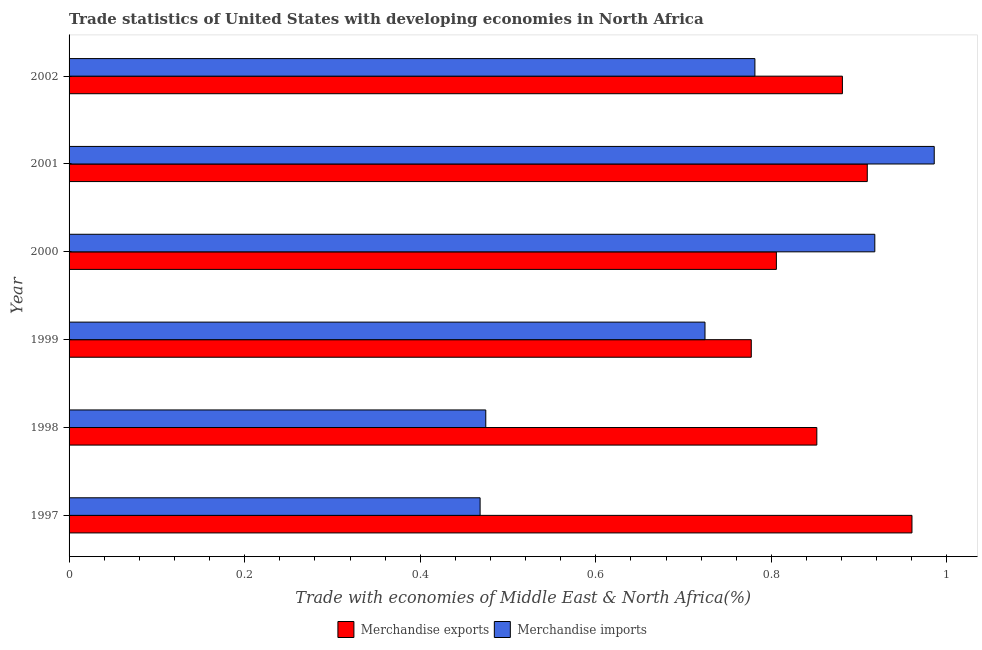How many different coloured bars are there?
Provide a short and direct response. 2. Are the number of bars per tick equal to the number of legend labels?
Your response must be concise. Yes. How many bars are there on the 6th tick from the top?
Give a very brief answer. 2. What is the label of the 3rd group of bars from the top?
Offer a terse response. 2000. What is the merchandise exports in 1997?
Keep it short and to the point. 0.96. Across all years, what is the maximum merchandise imports?
Keep it short and to the point. 0.99. Across all years, what is the minimum merchandise exports?
Give a very brief answer. 0.78. In which year was the merchandise imports maximum?
Provide a short and direct response. 2001. In which year was the merchandise imports minimum?
Offer a terse response. 1997. What is the total merchandise exports in the graph?
Your answer should be very brief. 5.18. What is the difference between the merchandise imports in 1998 and that in 2000?
Your response must be concise. -0.44. What is the difference between the merchandise imports in 2002 and the merchandise exports in 1998?
Offer a terse response. -0.07. What is the average merchandise exports per year?
Offer a terse response. 0.86. In the year 2000, what is the difference between the merchandise imports and merchandise exports?
Give a very brief answer. 0.11. In how many years, is the merchandise exports greater than 0.7200000000000001 %?
Your answer should be very brief. 6. What is the ratio of the merchandise imports in 2001 to that in 2002?
Offer a terse response. 1.26. Is the merchandise exports in 1997 less than that in 2002?
Offer a terse response. No. What is the difference between the highest and the second highest merchandise imports?
Your answer should be very brief. 0.07. What is the difference between the highest and the lowest merchandise exports?
Your response must be concise. 0.18. What does the 1st bar from the top in 1999 represents?
Provide a short and direct response. Merchandise imports. What does the 2nd bar from the bottom in 2001 represents?
Your answer should be very brief. Merchandise imports. How many bars are there?
Give a very brief answer. 12. Are all the bars in the graph horizontal?
Provide a succinct answer. Yes. What is the difference between two consecutive major ticks on the X-axis?
Ensure brevity in your answer.  0.2. Are the values on the major ticks of X-axis written in scientific E-notation?
Your answer should be compact. No. Where does the legend appear in the graph?
Provide a succinct answer. Bottom center. What is the title of the graph?
Keep it short and to the point. Trade statistics of United States with developing economies in North Africa. Does "Chemicals" appear as one of the legend labels in the graph?
Give a very brief answer. No. What is the label or title of the X-axis?
Give a very brief answer. Trade with economies of Middle East & North Africa(%). What is the Trade with economies of Middle East & North Africa(%) of Merchandise exports in 1997?
Offer a very short reply. 0.96. What is the Trade with economies of Middle East & North Africa(%) in Merchandise imports in 1997?
Your answer should be very brief. 0.47. What is the Trade with economies of Middle East & North Africa(%) in Merchandise exports in 1998?
Provide a succinct answer. 0.85. What is the Trade with economies of Middle East & North Africa(%) in Merchandise imports in 1998?
Your answer should be compact. 0.47. What is the Trade with economies of Middle East & North Africa(%) of Merchandise exports in 1999?
Your answer should be very brief. 0.78. What is the Trade with economies of Middle East & North Africa(%) in Merchandise imports in 1999?
Your response must be concise. 0.72. What is the Trade with economies of Middle East & North Africa(%) in Merchandise exports in 2000?
Ensure brevity in your answer.  0.81. What is the Trade with economies of Middle East & North Africa(%) of Merchandise imports in 2000?
Provide a succinct answer. 0.92. What is the Trade with economies of Middle East & North Africa(%) of Merchandise exports in 2001?
Your response must be concise. 0.91. What is the Trade with economies of Middle East & North Africa(%) in Merchandise imports in 2001?
Your response must be concise. 0.99. What is the Trade with economies of Middle East & North Africa(%) in Merchandise exports in 2002?
Provide a short and direct response. 0.88. What is the Trade with economies of Middle East & North Africa(%) in Merchandise imports in 2002?
Your answer should be very brief. 0.78. Across all years, what is the maximum Trade with economies of Middle East & North Africa(%) of Merchandise exports?
Provide a succinct answer. 0.96. Across all years, what is the maximum Trade with economies of Middle East & North Africa(%) of Merchandise imports?
Give a very brief answer. 0.99. Across all years, what is the minimum Trade with economies of Middle East & North Africa(%) of Merchandise exports?
Provide a succinct answer. 0.78. Across all years, what is the minimum Trade with economies of Middle East & North Africa(%) in Merchandise imports?
Your answer should be compact. 0.47. What is the total Trade with economies of Middle East & North Africa(%) of Merchandise exports in the graph?
Keep it short and to the point. 5.18. What is the total Trade with economies of Middle East & North Africa(%) of Merchandise imports in the graph?
Offer a terse response. 4.35. What is the difference between the Trade with economies of Middle East & North Africa(%) of Merchandise exports in 1997 and that in 1998?
Ensure brevity in your answer.  0.11. What is the difference between the Trade with economies of Middle East & North Africa(%) in Merchandise imports in 1997 and that in 1998?
Ensure brevity in your answer.  -0.01. What is the difference between the Trade with economies of Middle East & North Africa(%) in Merchandise exports in 1997 and that in 1999?
Keep it short and to the point. 0.18. What is the difference between the Trade with economies of Middle East & North Africa(%) of Merchandise imports in 1997 and that in 1999?
Ensure brevity in your answer.  -0.26. What is the difference between the Trade with economies of Middle East & North Africa(%) of Merchandise exports in 1997 and that in 2000?
Make the answer very short. 0.15. What is the difference between the Trade with economies of Middle East & North Africa(%) in Merchandise imports in 1997 and that in 2000?
Your answer should be very brief. -0.45. What is the difference between the Trade with economies of Middle East & North Africa(%) in Merchandise exports in 1997 and that in 2001?
Offer a terse response. 0.05. What is the difference between the Trade with economies of Middle East & North Africa(%) of Merchandise imports in 1997 and that in 2001?
Provide a succinct answer. -0.52. What is the difference between the Trade with economies of Middle East & North Africa(%) in Merchandise exports in 1997 and that in 2002?
Provide a succinct answer. 0.08. What is the difference between the Trade with economies of Middle East & North Africa(%) of Merchandise imports in 1997 and that in 2002?
Provide a succinct answer. -0.31. What is the difference between the Trade with economies of Middle East & North Africa(%) in Merchandise exports in 1998 and that in 1999?
Your response must be concise. 0.07. What is the difference between the Trade with economies of Middle East & North Africa(%) in Merchandise imports in 1998 and that in 1999?
Provide a short and direct response. -0.25. What is the difference between the Trade with economies of Middle East & North Africa(%) of Merchandise exports in 1998 and that in 2000?
Offer a very short reply. 0.05. What is the difference between the Trade with economies of Middle East & North Africa(%) in Merchandise imports in 1998 and that in 2000?
Your response must be concise. -0.44. What is the difference between the Trade with economies of Middle East & North Africa(%) in Merchandise exports in 1998 and that in 2001?
Ensure brevity in your answer.  -0.06. What is the difference between the Trade with economies of Middle East & North Africa(%) of Merchandise imports in 1998 and that in 2001?
Offer a terse response. -0.51. What is the difference between the Trade with economies of Middle East & North Africa(%) of Merchandise exports in 1998 and that in 2002?
Your answer should be very brief. -0.03. What is the difference between the Trade with economies of Middle East & North Africa(%) in Merchandise imports in 1998 and that in 2002?
Give a very brief answer. -0.31. What is the difference between the Trade with economies of Middle East & North Africa(%) of Merchandise exports in 1999 and that in 2000?
Your response must be concise. -0.03. What is the difference between the Trade with economies of Middle East & North Africa(%) of Merchandise imports in 1999 and that in 2000?
Give a very brief answer. -0.19. What is the difference between the Trade with economies of Middle East & North Africa(%) in Merchandise exports in 1999 and that in 2001?
Your answer should be compact. -0.13. What is the difference between the Trade with economies of Middle East & North Africa(%) of Merchandise imports in 1999 and that in 2001?
Your answer should be compact. -0.26. What is the difference between the Trade with economies of Middle East & North Africa(%) of Merchandise exports in 1999 and that in 2002?
Your response must be concise. -0.1. What is the difference between the Trade with economies of Middle East & North Africa(%) of Merchandise imports in 1999 and that in 2002?
Your response must be concise. -0.06. What is the difference between the Trade with economies of Middle East & North Africa(%) in Merchandise exports in 2000 and that in 2001?
Give a very brief answer. -0.1. What is the difference between the Trade with economies of Middle East & North Africa(%) of Merchandise imports in 2000 and that in 2001?
Your response must be concise. -0.07. What is the difference between the Trade with economies of Middle East & North Africa(%) of Merchandise exports in 2000 and that in 2002?
Offer a terse response. -0.08. What is the difference between the Trade with economies of Middle East & North Africa(%) in Merchandise imports in 2000 and that in 2002?
Your answer should be very brief. 0.14. What is the difference between the Trade with economies of Middle East & North Africa(%) of Merchandise exports in 2001 and that in 2002?
Your answer should be very brief. 0.03. What is the difference between the Trade with economies of Middle East & North Africa(%) of Merchandise imports in 2001 and that in 2002?
Your answer should be very brief. 0.2. What is the difference between the Trade with economies of Middle East & North Africa(%) in Merchandise exports in 1997 and the Trade with economies of Middle East & North Africa(%) in Merchandise imports in 1998?
Keep it short and to the point. 0.49. What is the difference between the Trade with economies of Middle East & North Africa(%) in Merchandise exports in 1997 and the Trade with economies of Middle East & North Africa(%) in Merchandise imports in 1999?
Provide a succinct answer. 0.24. What is the difference between the Trade with economies of Middle East & North Africa(%) of Merchandise exports in 1997 and the Trade with economies of Middle East & North Africa(%) of Merchandise imports in 2000?
Offer a terse response. 0.04. What is the difference between the Trade with economies of Middle East & North Africa(%) of Merchandise exports in 1997 and the Trade with economies of Middle East & North Africa(%) of Merchandise imports in 2001?
Offer a terse response. -0.03. What is the difference between the Trade with economies of Middle East & North Africa(%) of Merchandise exports in 1997 and the Trade with economies of Middle East & North Africa(%) of Merchandise imports in 2002?
Offer a very short reply. 0.18. What is the difference between the Trade with economies of Middle East & North Africa(%) of Merchandise exports in 1998 and the Trade with economies of Middle East & North Africa(%) of Merchandise imports in 1999?
Ensure brevity in your answer.  0.13. What is the difference between the Trade with economies of Middle East & North Africa(%) of Merchandise exports in 1998 and the Trade with economies of Middle East & North Africa(%) of Merchandise imports in 2000?
Offer a very short reply. -0.07. What is the difference between the Trade with economies of Middle East & North Africa(%) of Merchandise exports in 1998 and the Trade with economies of Middle East & North Africa(%) of Merchandise imports in 2001?
Your response must be concise. -0.13. What is the difference between the Trade with economies of Middle East & North Africa(%) of Merchandise exports in 1998 and the Trade with economies of Middle East & North Africa(%) of Merchandise imports in 2002?
Your response must be concise. 0.07. What is the difference between the Trade with economies of Middle East & North Africa(%) of Merchandise exports in 1999 and the Trade with economies of Middle East & North Africa(%) of Merchandise imports in 2000?
Your answer should be very brief. -0.14. What is the difference between the Trade with economies of Middle East & North Africa(%) of Merchandise exports in 1999 and the Trade with economies of Middle East & North Africa(%) of Merchandise imports in 2001?
Ensure brevity in your answer.  -0.21. What is the difference between the Trade with economies of Middle East & North Africa(%) in Merchandise exports in 1999 and the Trade with economies of Middle East & North Africa(%) in Merchandise imports in 2002?
Offer a terse response. -0. What is the difference between the Trade with economies of Middle East & North Africa(%) of Merchandise exports in 2000 and the Trade with economies of Middle East & North Africa(%) of Merchandise imports in 2001?
Keep it short and to the point. -0.18. What is the difference between the Trade with economies of Middle East & North Africa(%) in Merchandise exports in 2000 and the Trade with economies of Middle East & North Africa(%) in Merchandise imports in 2002?
Your answer should be very brief. 0.02. What is the difference between the Trade with economies of Middle East & North Africa(%) of Merchandise exports in 2001 and the Trade with economies of Middle East & North Africa(%) of Merchandise imports in 2002?
Offer a very short reply. 0.13. What is the average Trade with economies of Middle East & North Africa(%) of Merchandise exports per year?
Give a very brief answer. 0.86. What is the average Trade with economies of Middle East & North Africa(%) in Merchandise imports per year?
Your answer should be very brief. 0.73. In the year 1997, what is the difference between the Trade with economies of Middle East & North Africa(%) in Merchandise exports and Trade with economies of Middle East & North Africa(%) in Merchandise imports?
Your response must be concise. 0.49. In the year 1998, what is the difference between the Trade with economies of Middle East & North Africa(%) of Merchandise exports and Trade with economies of Middle East & North Africa(%) of Merchandise imports?
Your answer should be very brief. 0.38. In the year 1999, what is the difference between the Trade with economies of Middle East & North Africa(%) of Merchandise exports and Trade with economies of Middle East & North Africa(%) of Merchandise imports?
Provide a short and direct response. 0.05. In the year 2000, what is the difference between the Trade with economies of Middle East & North Africa(%) in Merchandise exports and Trade with economies of Middle East & North Africa(%) in Merchandise imports?
Your answer should be compact. -0.11. In the year 2001, what is the difference between the Trade with economies of Middle East & North Africa(%) in Merchandise exports and Trade with economies of Middle East & North Africa(%) in Merchandise imports?
Provide a succinct answer. -0.08. In the year 2002, what is the difference between the Trade with economies of Middle East & North Africa(%) of Merchandise exports and Trade with economies of Middle East & North Africa(%) of Merchandise imports?
Give a very brief answer. 0.1. What is the ratio of the Trade with economies of Middle East & North Africa(%) in Merchandise exports in 1997 to that in 1998?
Your answer should be compact. 1.13. What is the ratio of the Trade with economies of Middle East & North Africa(%) of Merchandise imports in 1997 to that in 1998?
Your answer should be compact. 0.99. What is the ratio of the Trade with economies of Middle East & North Africa(%) of Merchandise exports in 1997 to that in 1999?
Give a very brief answer. 1.24. What is the ratio of the Trade with economies of Middle East & North Africa(%) of Merchandise imports in 1997 to that in 1999?
Offer a very short reply. 0.65. What is the ratio of the Trade with economies of Middle East & North Africa(%) of Merchandise exports in 1997 to that in 2000?
Make the answer very short. 1.19. What is the ratio of the Trade with economies of Middle East & North Africa(%) in Merchandise imports in 1997 to that in 2000?
Make the answer very short. 0.51. What is the ratio of the Trade with economies of Middle East & North Africa(%) in Merchandise exports in 1997 to that in 2001?
Your response must be concise. 1.06. What is the ratio of the Trade with economies of Middle East & North Africa(%) in Merchandise imports in 1997 to that in 2001?
Keep it short and to the point. 0.48. What is the ratio of the Trade with economies of Middle East & North Africa(%) in Merchandise exports in 1997 to that in 2002?
Give a very brief answer. 1.09. What is the ratio of the Trade with economies of Middle East & North Africa(%) in Merchandise imports in 1997 to that in 2002?
Give a very brief answer. 0.6. What is the ratio of the Trade with economies of Middle East & North Africa(%) in Merchandise exports in 1998 to that in 1999?
Give a very brief answer. 1.1. What is the ratio of the Trade with economies of Middle East & North Africa(%) of Merchandise imports in 1998 to that in 1999?
Your answer should be very brief. 0.66. What is the ratio of the Trade with economies of Middle East & North Africa(%) in Merchandise exports in 1998 to that in 2000?
Your response must be concise. 1.06. What is the ratio of the Trade with economies of Middle East & North Africa(%) of Merchandise imports in 1998 to that in 2000?
Keep it short and to the point. 0.52. What is the ratio of the Trade with economies of Middle East & North Africa(%) of Merchandise exports in 1998 to that in 2001?
Offer a very short reply. 0.94. What is the ratio of the Trade with economies of Middle East & North Africa(%) in Merchandise imports in 1998 to that in 2001?
Keep it short and to the point. 0.48. What is the ratio of the Trade with economies of Middle East & North Africa(%) of Merchandise exports in 1998 to that in 2002?
Give a very brief answer. 0.97. What is the ratio of the Trade with economies of Middle East & North Africa(%) of Merchandise imports in 1998 to that in 2002?
Offer a terse response. 0.61. What is the ratio of the Trade with economies of Middle East & North Africa(%) in Merchandise exports in 1999 to that in 2000?
Give a very brief answer. 0.96. What is the ratio of the Trade with economies of Middle East & North Africa(%) in Merchandise imports in 1999 to that in 2000?
Provide a short and direct response. 0.79. What is the ratio of the Trade with economies of Middle East & North Africa(%) in Merchandise exports in 1999 to that in 2001?
Give a very brief answer. 0.85. What is the ratio of the Trade with economies of Middle East & North Africa(%) of Merchandise imports in 1999 to that in 2001?
Provide a succinct answer. 0.73. What is the ratio of the Trade with economies of Middle East & North Africa(%) in Merchandise exports in 1999 to that in 2002?
Your response must be concise. 0.88. What is the ratio of the Trade with economies of Middle East & North Africa(%) of Merchandise imports in 1999 to that in 2002?
Provide a short and direct response. 0.93. What is the ratio of the Trade with economies of Middle East & North Africa(%) in Merchandise exports in 2000 to that in 2001?
Your response must be concise. 0.89. What is the ratio of the Trade with economies of Middle East & North Africa(%) of Merchandise imports in 2000 to that in 2001?
Give a very brief answer. 0.93. What is the ratio of the Trade with economies of Middle East & North Africa(%) in Merchandise exports in 2000 to that in 2002?
Offer a terse response. 0.91. What is the ratio of the Trade with economies of Middle East & North Africa(%) of Merchandise imports in 2000 to that in 2002?
Offer a very short reply. 1.17. What is the ratio of the Trade with economies of Middle East & North Africa(%) in Merchandise exports in 2001 to that in 2002?
Give a very brief answer. 1.03. What is the ratio of the Trade with economies of Middle East & North Africa(%) of Merchandise imports in 2001 to that in 2002?
Your response must be concise. 1.26. What is the difference between the highest and the second highest Trade with economies of Middle East & North Africa(%) in Merchandise exports?
Offer a terse response. 0.05. What is the difference between the highest and the second highest Trade with economies of Middle East & North Africa(%) in Merchandise imports?
Provide a short and direct response. 0.07. What is the difference between the highest and the lowest Trade with economies of Middle East & North Africa(%) in Merchandise exports?
Your answer should be compact. 0.18. What is the difference between the highest and the lowest Trade with economies of Middle East & North Africa(%) of Merchandise imports?
Give a very brief answer. 0.52. 